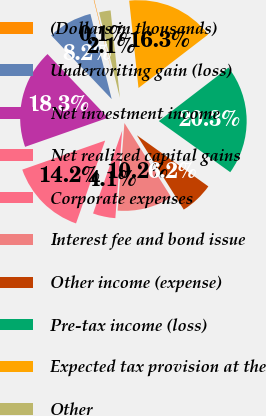Convert chart. <chart><loc_0><loc_0><loc_500><loc_500><pie_chart><fcel>(Dollars in thousands)<fcel>Underwriting gain (loss)<fcel>Net investment income<fcel>Net realized capital gains<fcel>Corporate expenses<fcel>Interest fee and bond issue<fcel>Other income (expense)<fcel>Pre-tax income (loss)<fcel>Expected tax provision at the<fcel>Other<nl><fcel>0.09%<fcel>8.18%<fcel>18.29%<fcel>14.25%<fcel>4.14%<fcel>10.2%<fcel>6.16%<fcel>20.31%<fcel>16.27%<fcel>2.12%<nl></chart> 